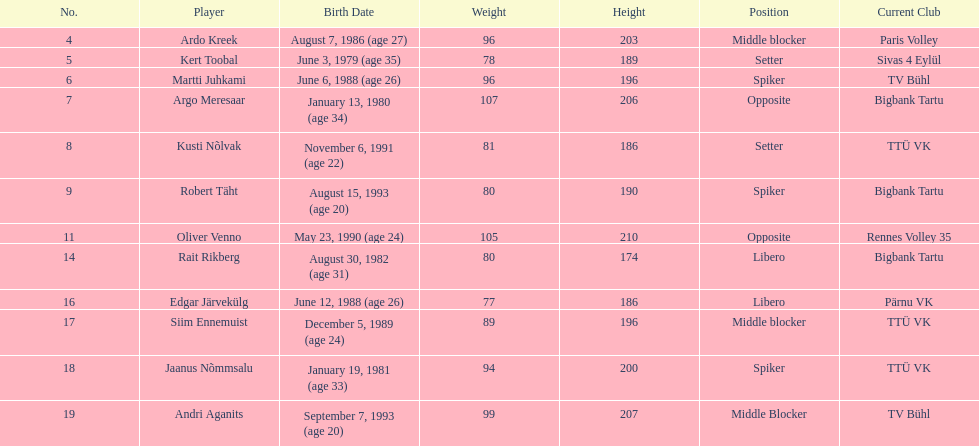Which player is taller than andri agantis? Oliver Venno. 